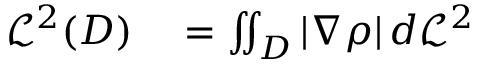<formula> <loc_0><loc_0><loc_500><loc_500>\begin{array} { r l } { { \mathcal { L } } ^ { 2 } ( D ) } & = \iint _ { D } | \nabla \rho | \, d { \mathcal { L } } ^ { 2 } } \end{array}</formula> 